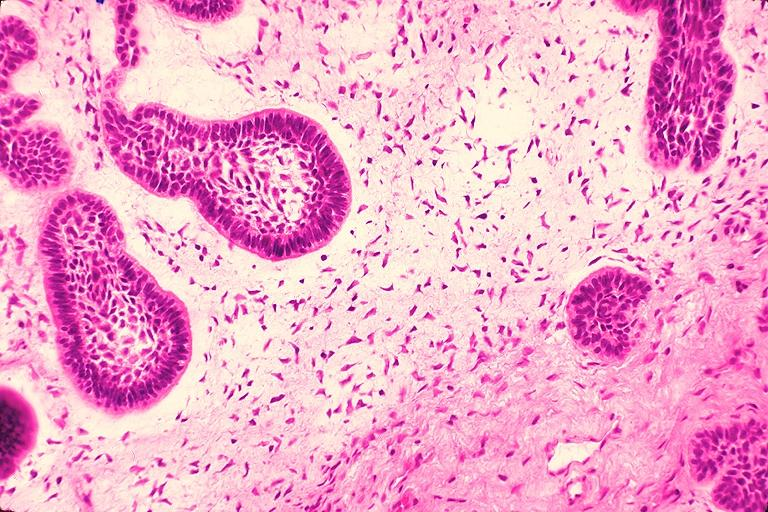s lewy body present?
Answer the question using a single word or phrase. No 